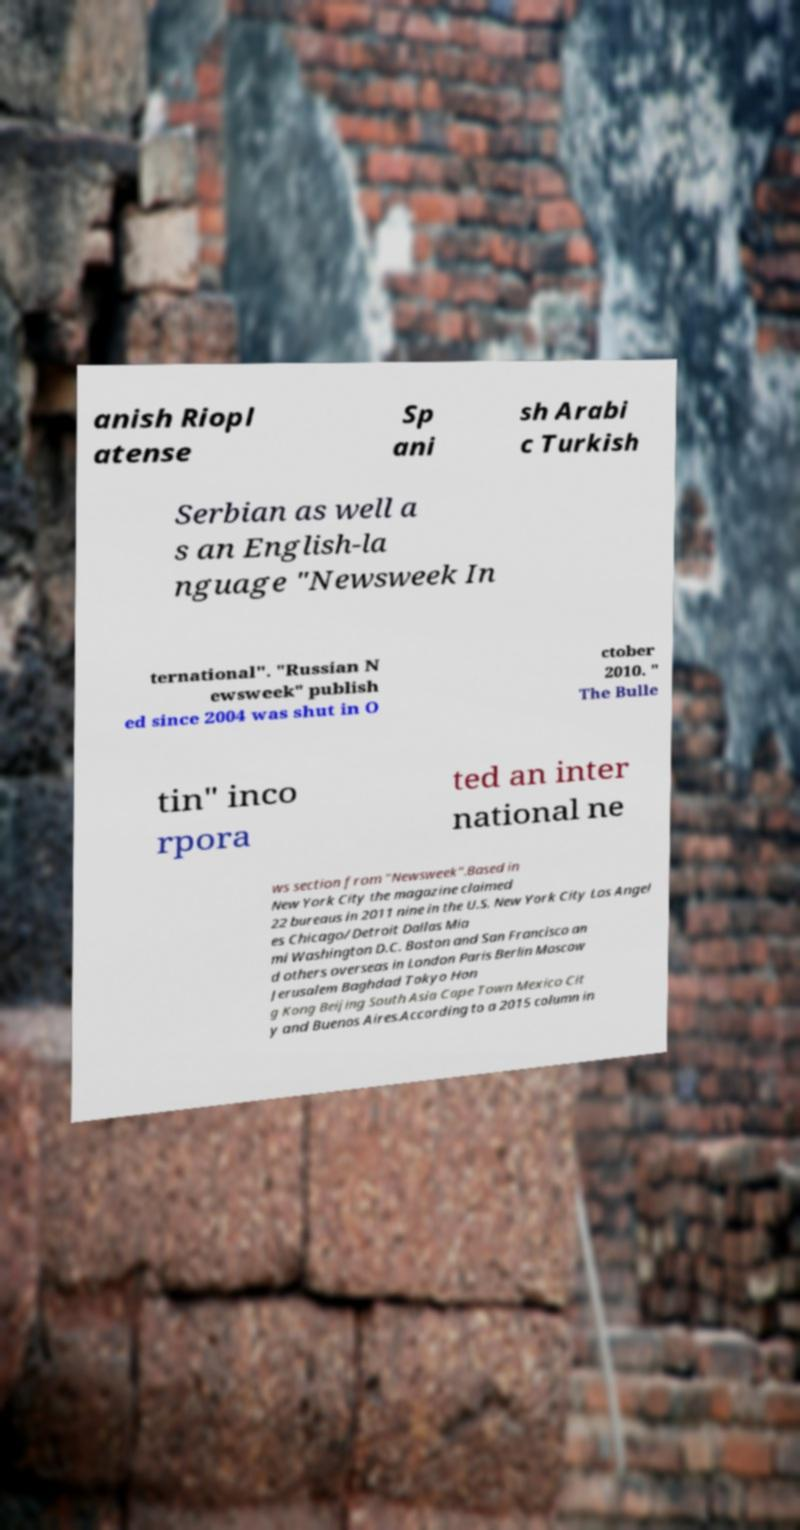There's text embedded in this image that I need extracted. Can you transcribe it verbatim? anish Riopl atense Sp ani sh Arabi c Turkish Serbian as well a s an English-la nguage "Newsweek In ternational". "Russian N ewsweek" publish ed since 2004 was shut in O ctober 2010. " The Bulle tin" inco rpora ted an inter national ne ws section from "Newsweek".Based in New York City the magazine claimed 22 bureaus in 2011 nine in the U.S. New York City Los Angel es Chicago/Detroit Dallas Mia mi Washington D.C. Boston and San Francisco an d others overseas in London Paris Berlin Moscow Jerusalem Baghdad Tokyo Hon g Kong Beijing South Asia Cape Town Mexico Cit y and Buenos Aires.According to a 2015 column in 